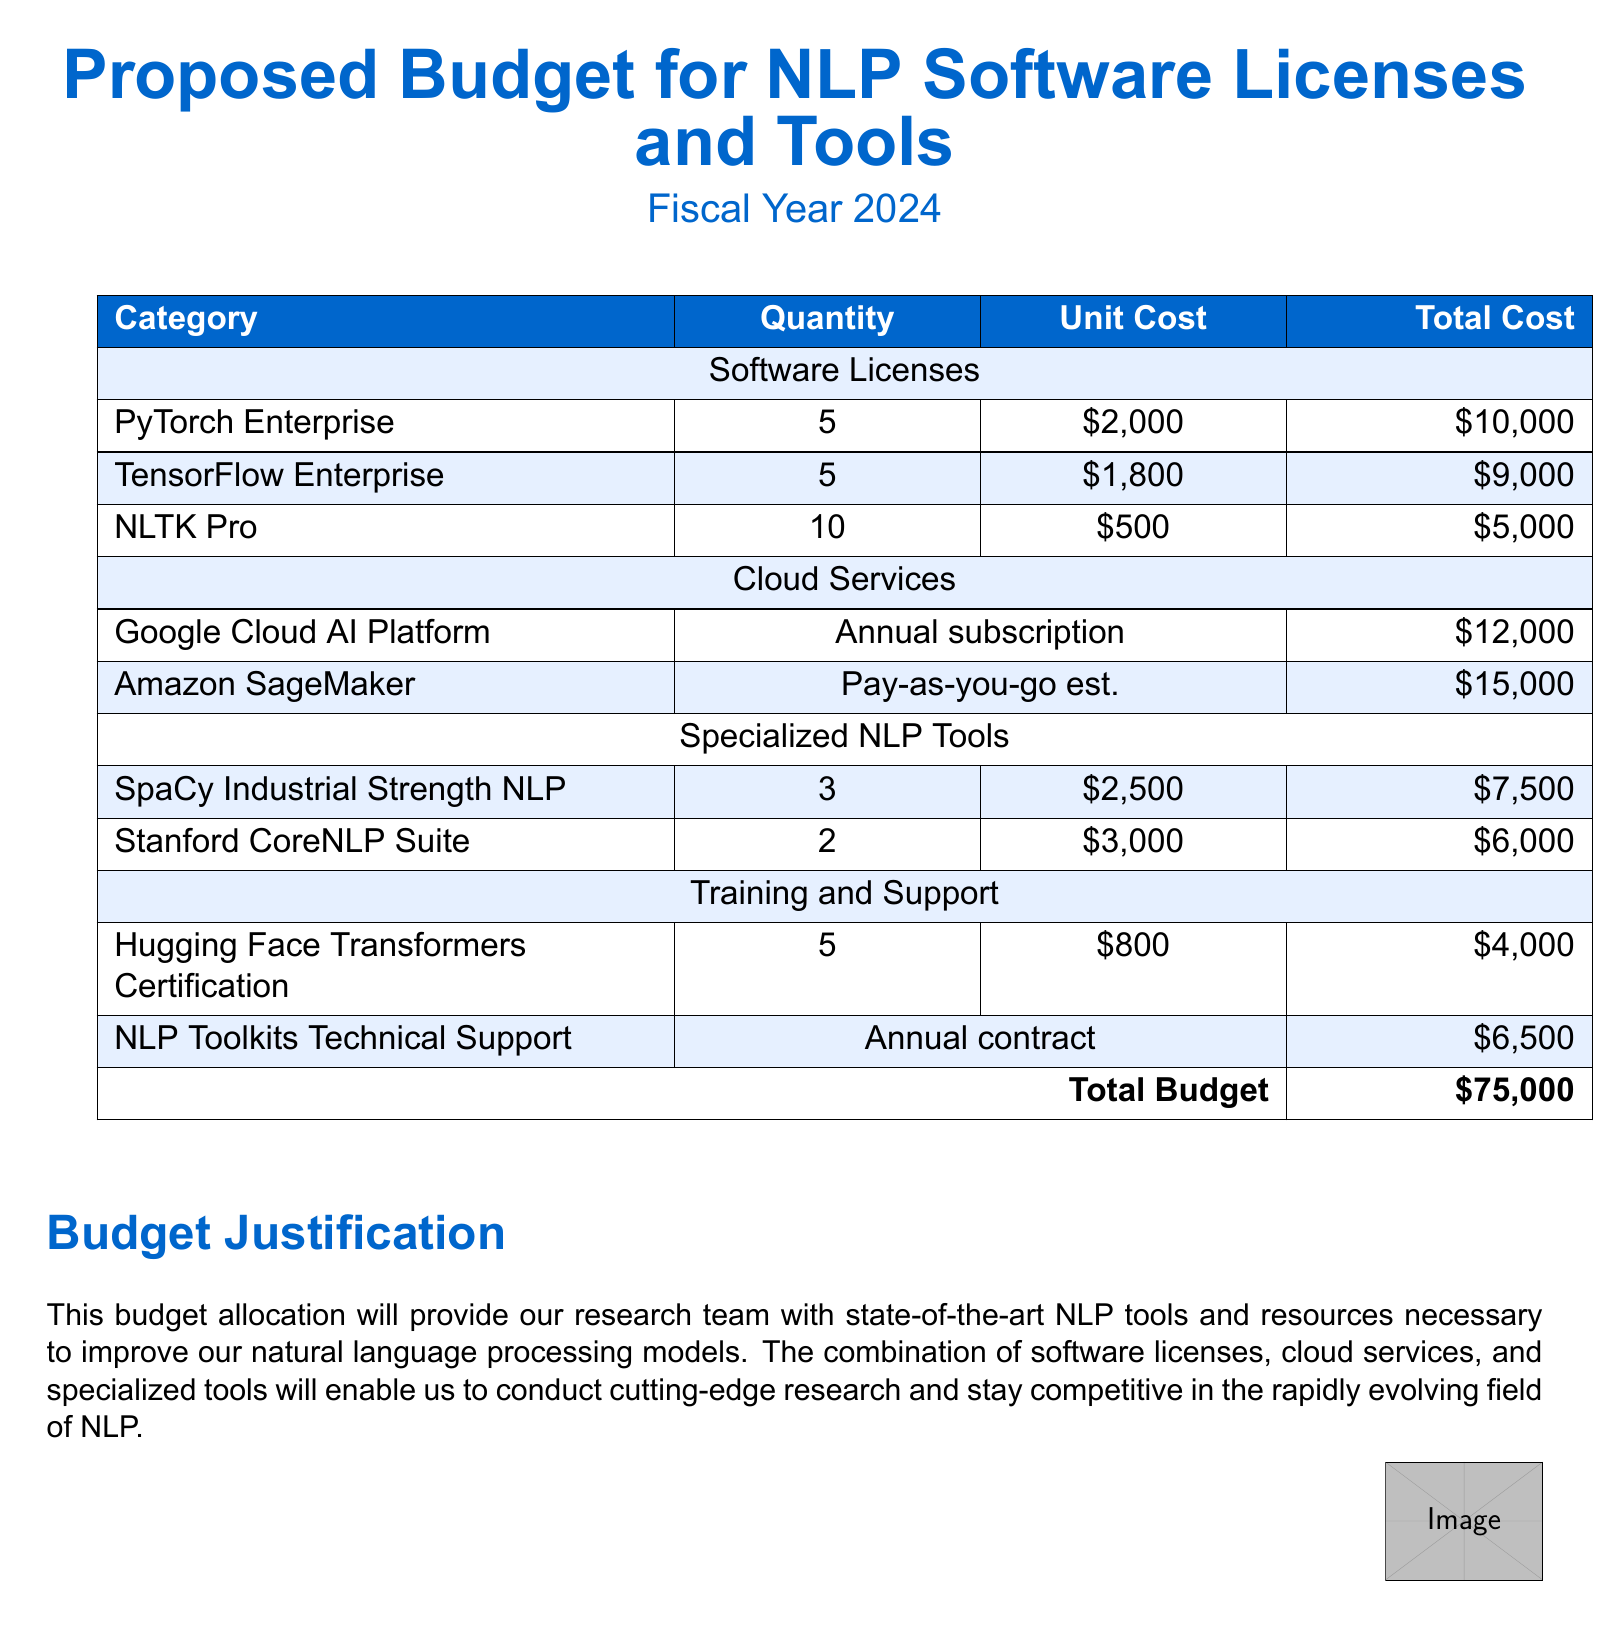What is the total budget? The total budget is explicitly stated at the bottom of the table in the document.
Answer: $75,000 How many licenses for PyTorch Enterprise are proposed? The document indicates the quantity of PyTorch Enterprise licenses in the budget table under Software Licenses.
Answer: 5 What is the unit cost of TensorFlow Enterprise? The unit cost is mentioned in the budget table for TensorFlow Enterprise under Software Licenses.
Answer: $1,800 What is the total cost for SpaCy Industrial Strength NLP? The total cost is calculated as the product of quantity and unit cost for SpaCy Industrial Strength NLP in the budget table.
Answer: $7,500 What type of subscription is proposed for Google Cloud AI Platform? The document specifies in the budget table that the Google Cloud AI Platform has an annual subscription model.
Answer: Annual subscription What is the quantity of NLTK Pro licenses? The quantity of NLTK Pro licenses can be found in the Software Licenses section of the budget table.
Answer: 10 How much is allocated for NLP Toolkits Technical Support? The allocation for NLP Toolkits Technical Support is listed in the Training and Support section of the budget table.
Answer: $6,500 Which license has the highest unit cost? By comparing the unit costs within the Software Licenses, it is evident which license has the highest cost.
Answer: PyTorch Enterprise How many certifications for Hugging Face Transformers are included? The number of certifications is explicitly stated in the budget table under Training and Support.
Answer: 5 